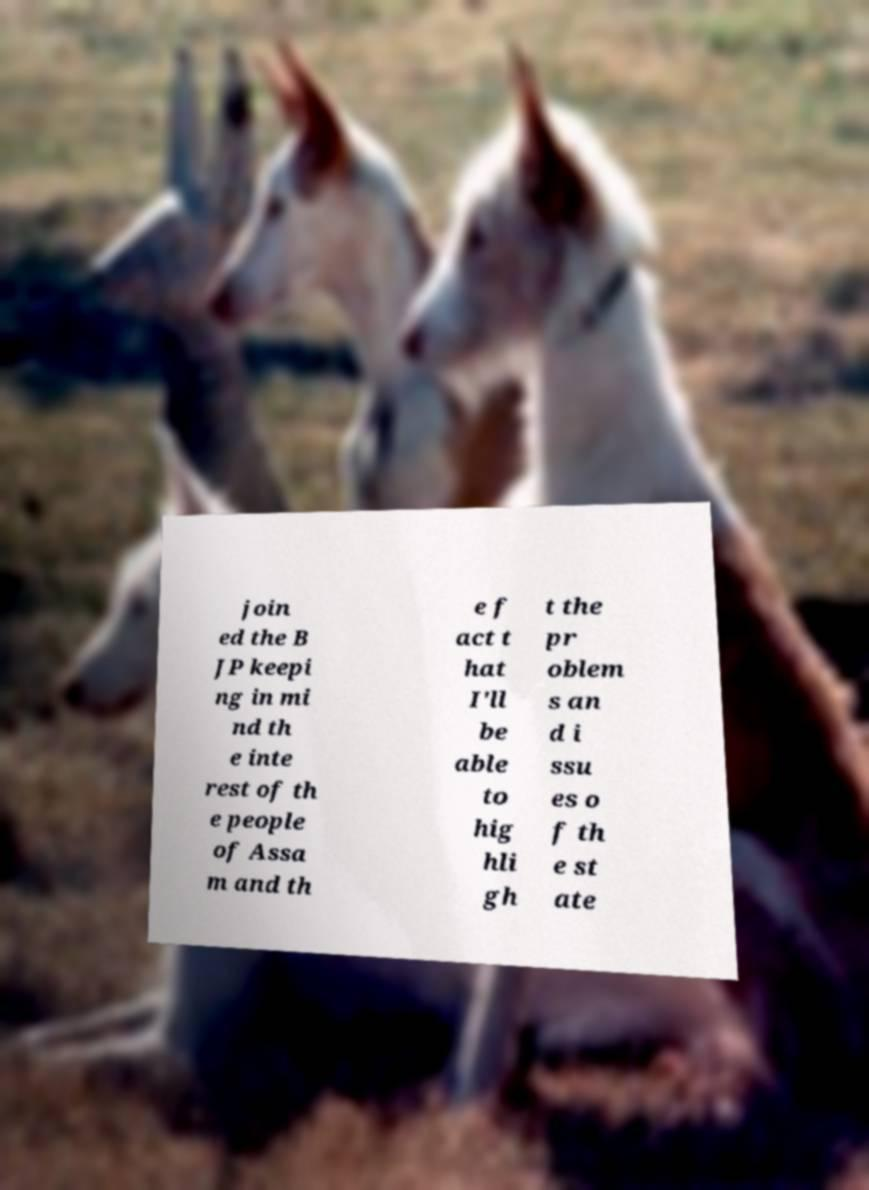Please identify and transcribe the text found in this image. join ed the B JP keepi ng in mi nd th e inte rest of th e people of Assa m and th e f act t hat I'll be able to hig hli gh t the pr oblem s an d i ssu es o f th e st ate 